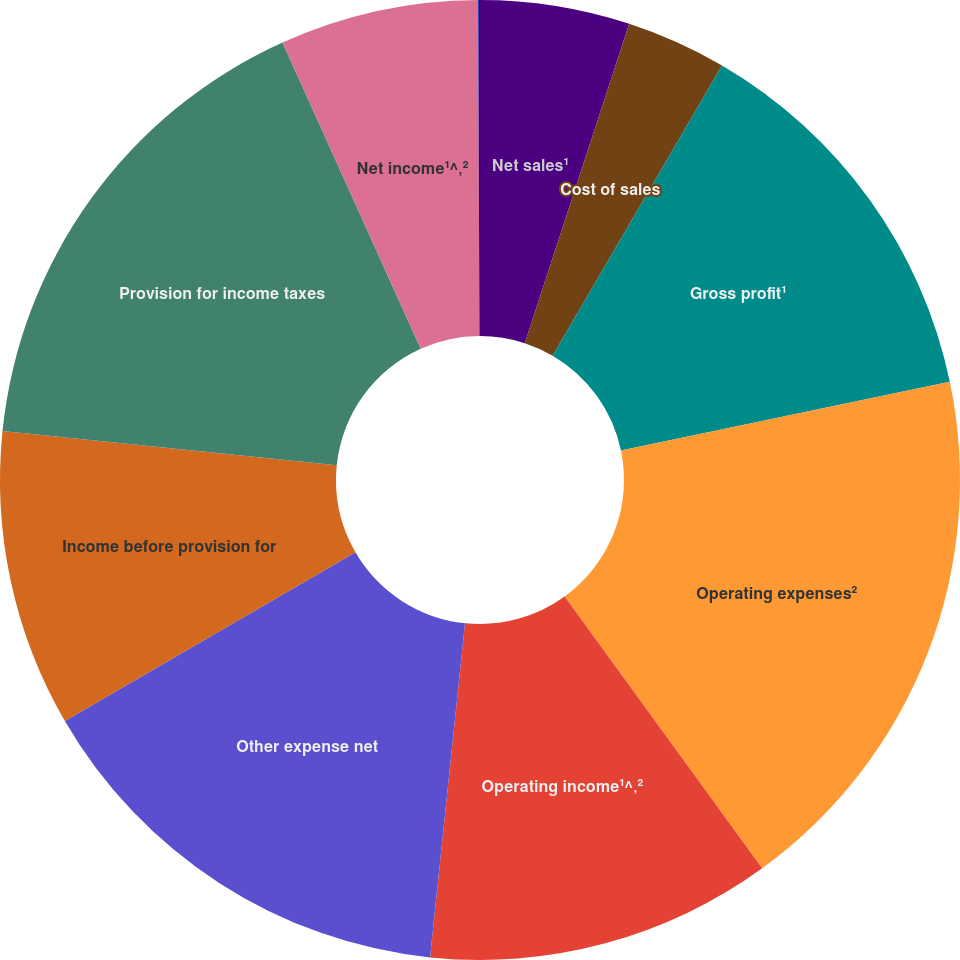<chart> <loc_0><loc_0><loc_500><loc_500><pie_chart><fcel>Net sales¹<fcel>Cost of sales<fcel>Gross profit¹<fcel>Operating expenses²<fcel>Operating income¹^‚²<fcel>Other expense net<fcel>Income before provision for<fcel>Provision for income taxes<fcel>Net income¹^‚²<fcel>Basic<nl><fcel>5.03%<fcel>3.38%<fcel>13.31%<fcel>18.28%<fcel>11.66%<fcel>14.97%<fcel>10.0%<fcel>16.62%<fcel>6.69%<fcel>0.06%<nl></chart> 